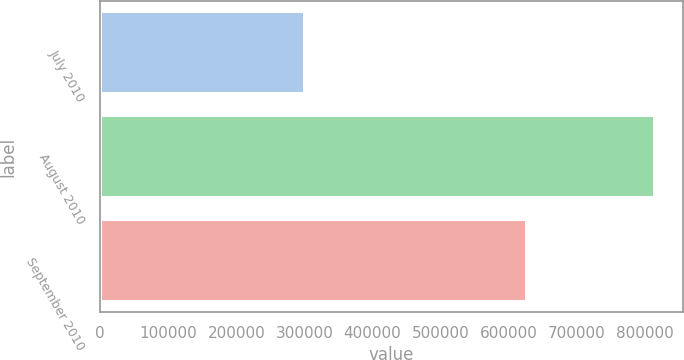Convert chart. <chart><loc_0><loc_0><loc_500><loc_500><bar_chart><fcel>July 2010<fcel>August 2010<fcel>September 2010<nl><fcel>300800<fcel>815300<fcel>626532<nl></chart> 